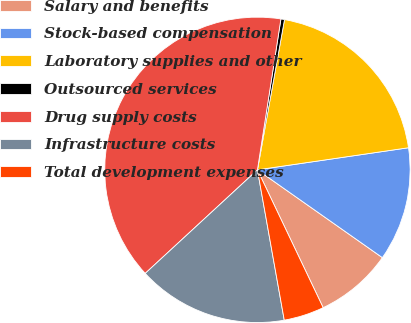Convert chart to OTSL. <chart><loc_0><loc_0><loc_500><loc_500><pie_chart><fcel>Salary and benefits<fcel>Stock-based compensation<fcel>Laboratory supplies and other<fcel>Outsourced services<fcel>Drug supply costs<fcel>Infrastructure costs<fcel>Total development expenses<nl><fcel>8.17%<fcel>12.06%<fcel>19.85%<fcel>0.38%<fcel>39.32%<fcel>15.95%<fcel>4.27%<nl></chart> 